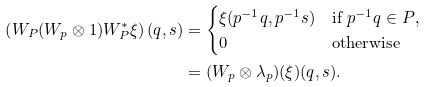<formula> <loc_0><loc_0><loc_500><loc_500>\left ( W _ { P } ( W _ { p } \otimes 1 ) W _ { P } ^ { * } \xi \right ) ( q , s ) & = \begin{cases} \xi ( p ^ { - 1 } q , p ^ { - 1 } s ) & \text {if $p^{-1}q\in P$,} \\ 0 & \text {otherwise} \\ \end{cases} \\ & = ( W _ { p } \otimes \lambda _ { p } ) ( \xi ) ( q , s ) .</formula> 